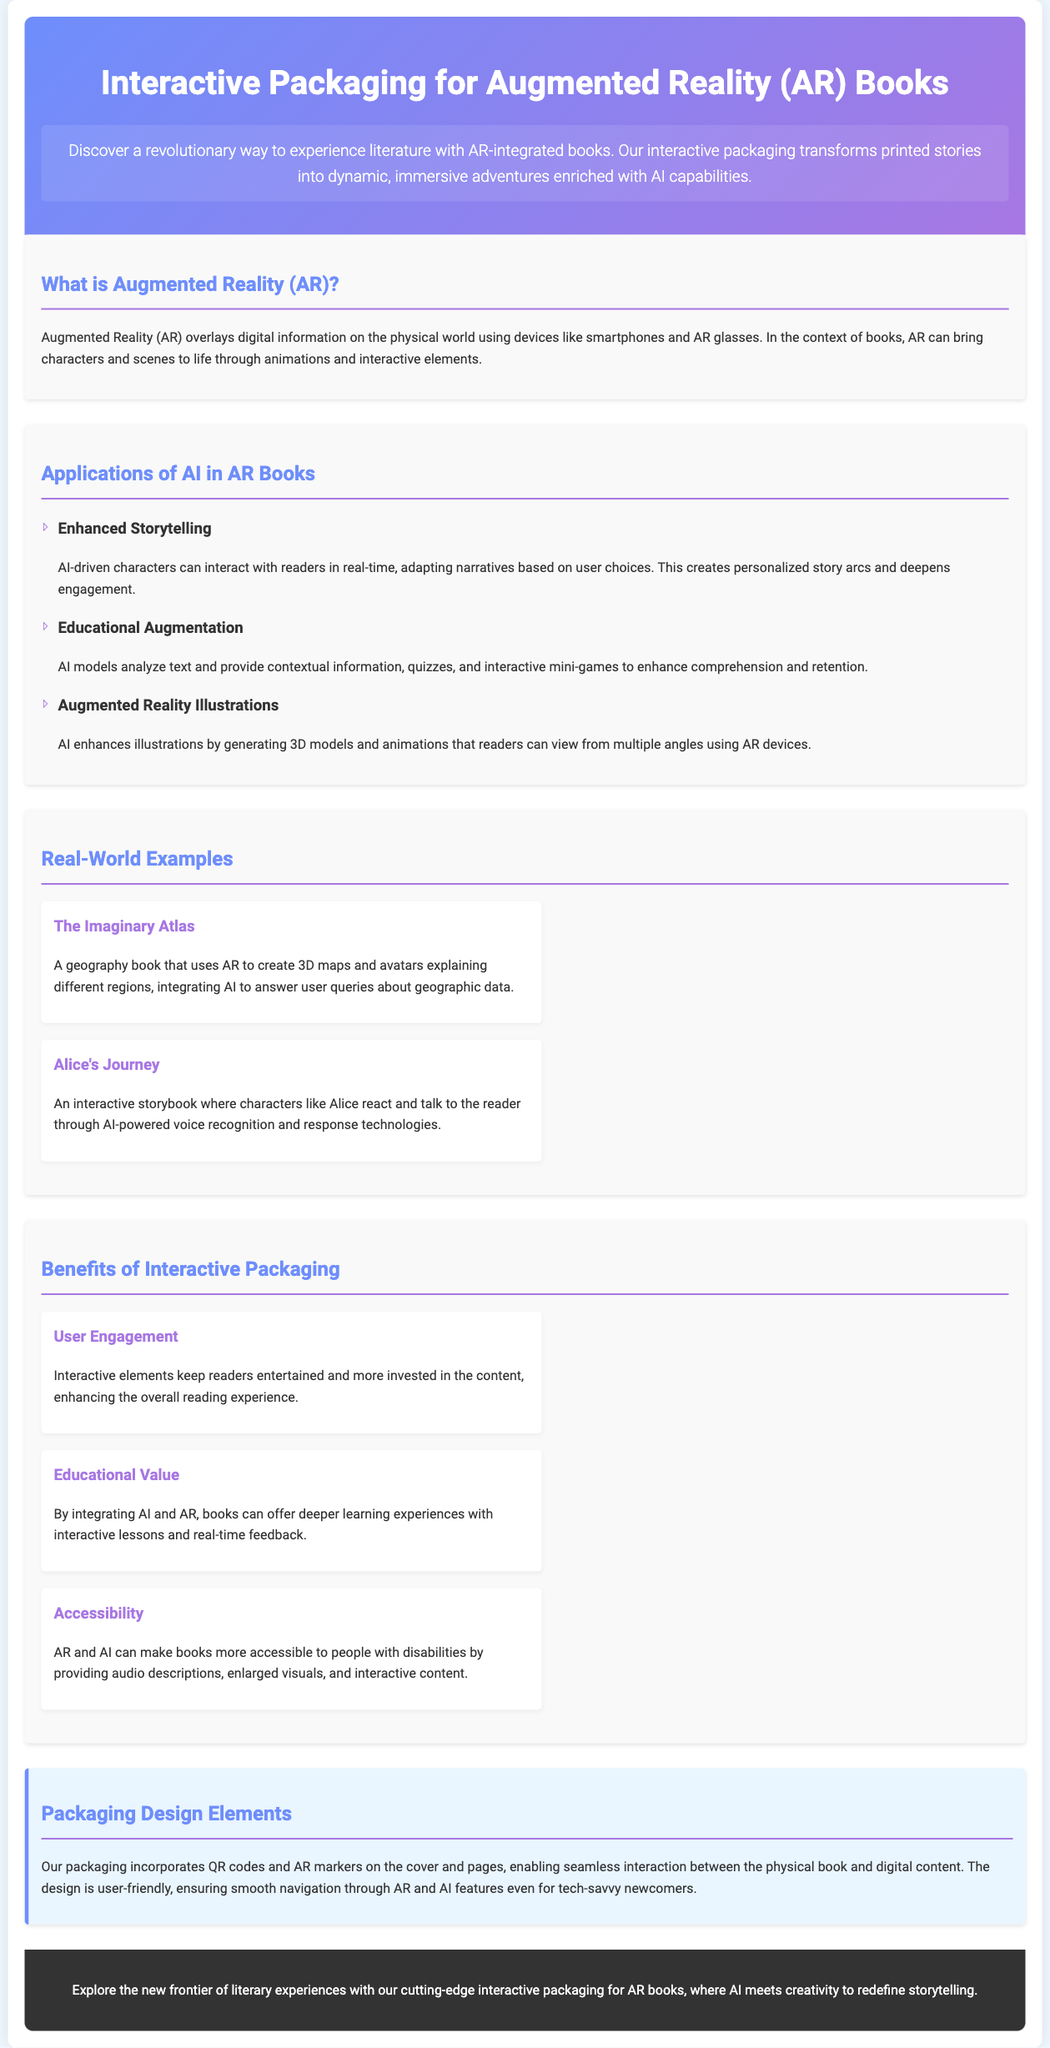What is the main purpose of the interactive packaging? The document states that the interactive packaging transforms printed stories into dynamic, immersive adventures enriched with AI capabilities.
Answer: Enhancing literary experiences What technology is used to overlay digital information? The document defines that Augmented Reality (AR) overlays digital information on the physical world using devices like smartphones and AR glasses.
Answer: Augmented Reality (AR) What type of characters do AI-driven stories include? The AI-driven characters can interact with readers in real-time, adapting narratives based on user choices, creating personalized story arcs.
Answer: AI-driven characters What geography book is mentioned as a real-world example? The document presents "The Imaginary Atlas" as a geography book that uses AR to create 3D maps and avatars.
Answer: The Imaginary Atlas What is one benefit of interactive packaging noted in the document? One benefit highlighted is that interactive elements keep readers entertained and more invested in the content.
Answer: User Engagement How does AI augment educational books? The document describes that AI models analyze text and provide contextual information, quizzes, and interactive mini-games to enhance comprehension.
Answer: Educational Augmentation What is a feature of the packaging design? The packaging incorporates QR codes and AR markers on the cover and pages for interaction with digital content.
Answer: QR codes and AR markers What is the primary audience for the AR books? The document implies that the design is user-friendly, targeting both tech-savvy newcomers and others interested in AR books.
Answer: Tech-savvy newcomers 